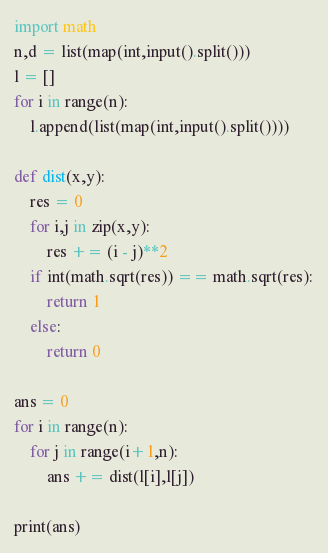Convert code to text. <code><loc_0><loc_0><loc_500><loc_500><_Python_>import math
n,d = list(map(int,input().split()))
l = []
for i in range(n):
    l.append(list(map(int,input().split())))

def dist(x,y):
    res = 0
    for i,j in zip(x,y):
        res += (i - j)**2
    if int(math.sqrt(res)) == math.sqrt(res):
        return 1
    else:
        return 0

ans = 0
for i in range(n):
    for j in range(i+1,n):
        ans += dist(l[i],l[j])

print(ans)</code> 